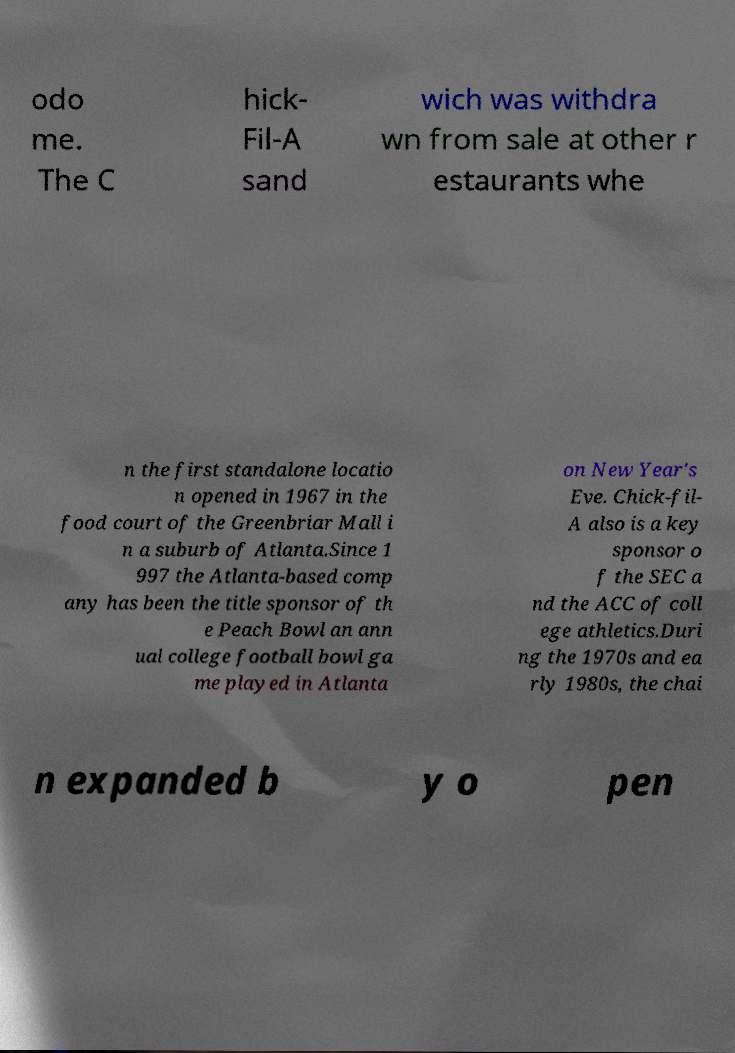Please identify and transcribe the text found in this image. odo me. The C hick- Fil-A sand wich was withdra wn from sale at other r estaurants whe n the first standalone locatio n opened in 1967 in the food court of the Greenbriar Mall i n a suburb of Atlanta.Since 1 997 the Atlanta-based comp any has been the title sponsor of th e Peach Bowl an ann ual college football bowl ga me played in Atlanta on New Year's Eve. Chick-fil- A also is a key sponsor o f the SEC a nd the ACC of coll ege athletics.Duri ng the 1970s and ea rly 1980s, the chai n expanded b y o pen 